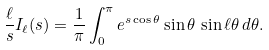<formula> <loc_0><loc_0><loc_500><loc_500>\frac { \ell } { s } I _ { \ell } ( s ) = \frac { 1 } \pi \int _ { 0 } ^ { \pi } e ^ { s \cos \theta } \sin \theta \, \sin \ell \theta \, d \theta .</formula> 